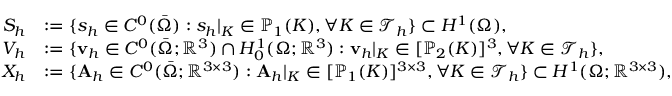<formula> <loc_0><loc_0><loc_500><loc_500>\begin{array} { r l } { S _ { h } } & { \colon = \{ s _ { h } \in C ^ { 0 } ( \bar { \Omega } ) \colon s _ { h } | _ { K } \in \mathbb { P } _ { 1 } ( K ) , \forall K \in \mathcal { T } _ { h } \} \subset H ^ { 1 } ( \Omega ) , } \\ { V _ { h } } & { \colon = \{ v _ { h } \in C ^ { 0 } ( \bar { \Omega } ; \mathbb { R } ^ { 3 } ) \cap H _ { 0 } ^ { 1 } ( \Omega ; \mathbb { R } ^ { 3 } ) \colon v _ { h } | _ { K } \in [ \mathbb { P } _ { 2 } ( K ) ] ^ { 3 } , \forall K \in \mathcal { T } _ { h } \} , } \\ { X _ { h } } & { \colon = \{ A _ { h } \in C ^ { 0 } ( \bar { \Omega } ; \mathbb { R } ^ { 3 \times 3 } ) \colon A _ { h } | _ { K } \in [ \mathbb { P } _ { 1 } ( K ) ] ^ { 3 \times 3 } , \forall K \in \mathcal { T } _ { h } \} \subset H ^ { 1 } ( \Omega ; \mathbb { R } ^ { 3 \times 3 } ) , } \end{array}</formula> 